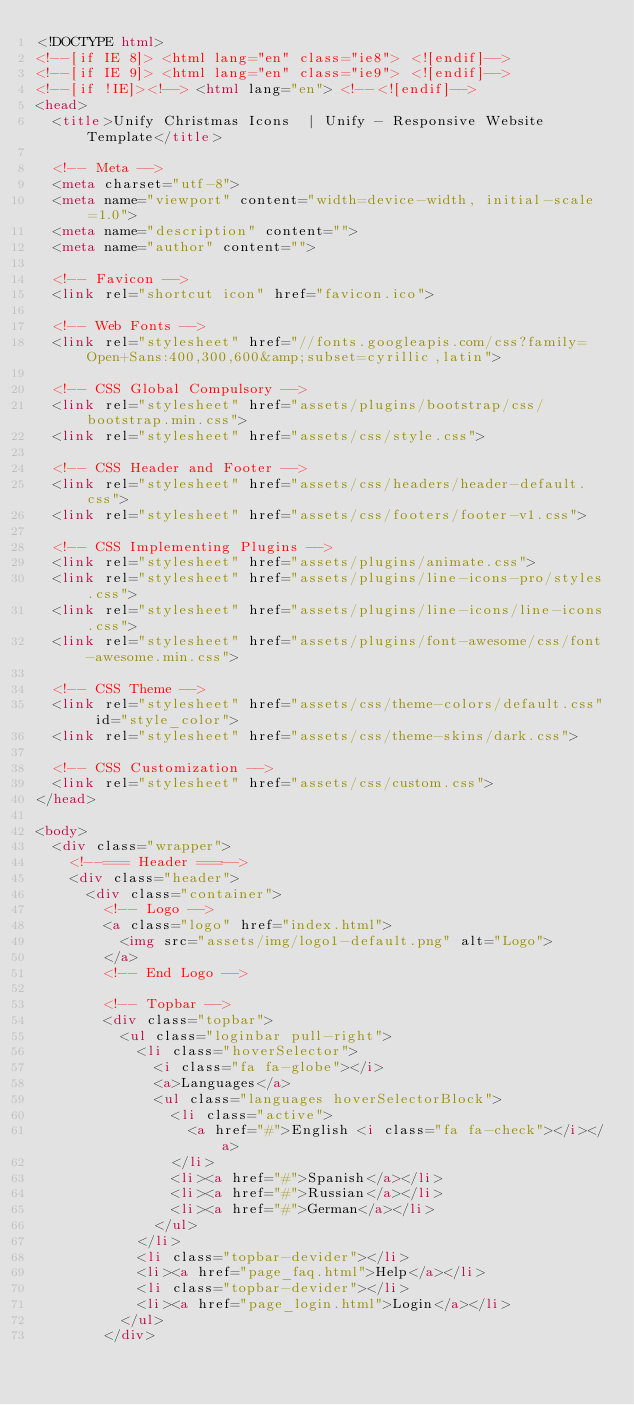<code> <loc_0><loc_0><loc_500><loc_500><_HTML_><!DOCTYPE html>
<!--[if IE 8]> <html lang="en" class="ie8"> <![endif]-->
<!--[if IE 9]> <html lang="en" class="ie9"> <![endif]-->
<!--[if !IE]><!--> <html lang="en"> <!--<![endif]-->
<head>
	<title>Unify Christmas Icons  | Unify - Responsive Website Template</title>

	<!-- Meta -->
	<meta charset="utf-8">
	<meta name="viewport" content="width=device-width, initial-scale=1.0">
	<meta name="description" content="">
	<meta name="author" content="">

	<!-- Favicon -->
	<link rel="shortcut icon" href="favicon.ico">

	<!-- Web Fonts -->
	<link rel="stylesheet" href="//fonts.googleapis.com/css?family=Open+Sans:400,300,600&amp;subset=cyrillic,latin">

	<!-- CSS Global Compulsory -->
	<link rel="stylesheet" href="assets/plugins/bootstrap/css/bootstrap.min.css">
	<link rel="stylesheet" href="assets/css/style.css">

	<!-- CSS Header and Footer -->
	<link rel="stylesheet" href="assets/css/headers/header-default.css">
	<link rel="stylesheet" href="assets/css/footers/footer-v1.css">

	<!-- CSS Implementing Plugins -->
	<link rel="stylesheet" href="assets/plugins/animate.css">
	<link rel="stylesheet" href="assets/plugins/line-icons-pro/styles.css">
	<link rel="stylesheet" href="assets/plugins/line-icons/line-icons.css">
	<link rel="stylesheet" href="assets/plugins/font-awesome/css/font-awesome.min.css">

	<!-- CSS Theme -->
	<link rel="stylesheet" href="assets/css/theme-colors/default.css" id="style_color">
	<link rel="stylesheet" href="assets/css/theme-skins/dark.css">

	<!-- CSS Customization -->
	<link rel="stylesheet" href="assets/css/custom.css">
</head>

<body>
	<div class="wrapper">
		<!--=== Header ===-->
		<div class="header">
			<div class="container">
				<!-- Logo -->
				<a class="logo" href="index.html">
					<img src="assets/img/logo1-default.png" alt="Logo">
				</a>
				<!-- End Logo -->

				<!-- Topbar -->
				<div class="topbar">
					<ul class="loginbar pull-right">
						<li class="hoverSelector">
							<i class="fa fa-globe"></i>
							<a>Languages</a>
							<ul class="languages hoverSelectorBlock">
								<li class="active">
									<a href="#">English <i class="fa fa-check"></i></a>
								</li>
								<li><a href="#">Spanish</a></li>
								<li><a href="#">Russian</a></li>
								<li><a href="#">German</a></li>
							</ul>
						</li>
						<li class="topbar-devider"></li>
						<li><a href="page_faq.html">Help</a></li>
						<li class="topbar-devider"></li>
						<li><a href="page_login.html">Login</a></li>
					</ul>
				</div></code> 